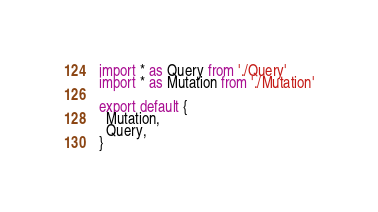<code> <loc_0><loc_0><loc_500><loc_500><_TypeScript_>import * as Query from './Query'
import * as Mutation from './Mutation'

export default {
  Mutation,
  Query,
}
</code> 